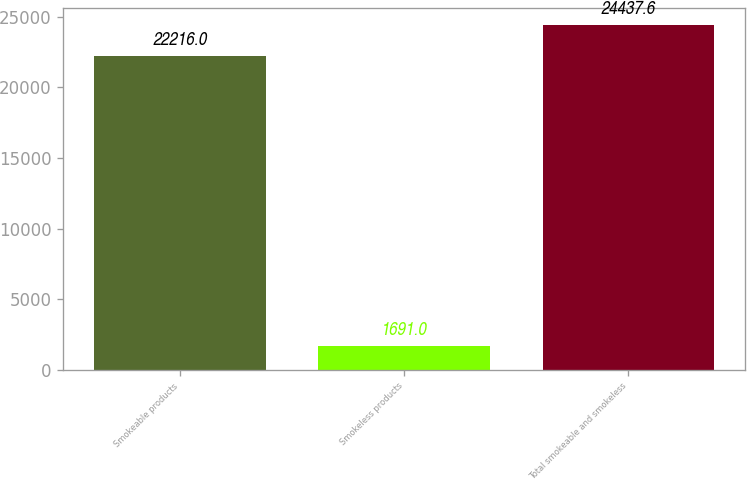Convert chart to OTSL. <chart><loc_0><loc_0><loc_500><loc_500><bar_chart><fcel>Smokeable products<fcel>Smokeless products<fcel>Total smokeable and smokeless<nl><fcel>22216<fcel>1691<fcel>24437.6<nl></chart> 